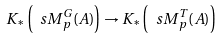Convert formula to latex. <formula><loc_0><loc_0><loc_500><loc_500>K _ { * } \left ( { \ s M } ^ { G } _ { p } ( A ) \right ) \to K _ { * } \left ( { \ s M } ^ { T } _ { p } ( A ) \right )</formula> 